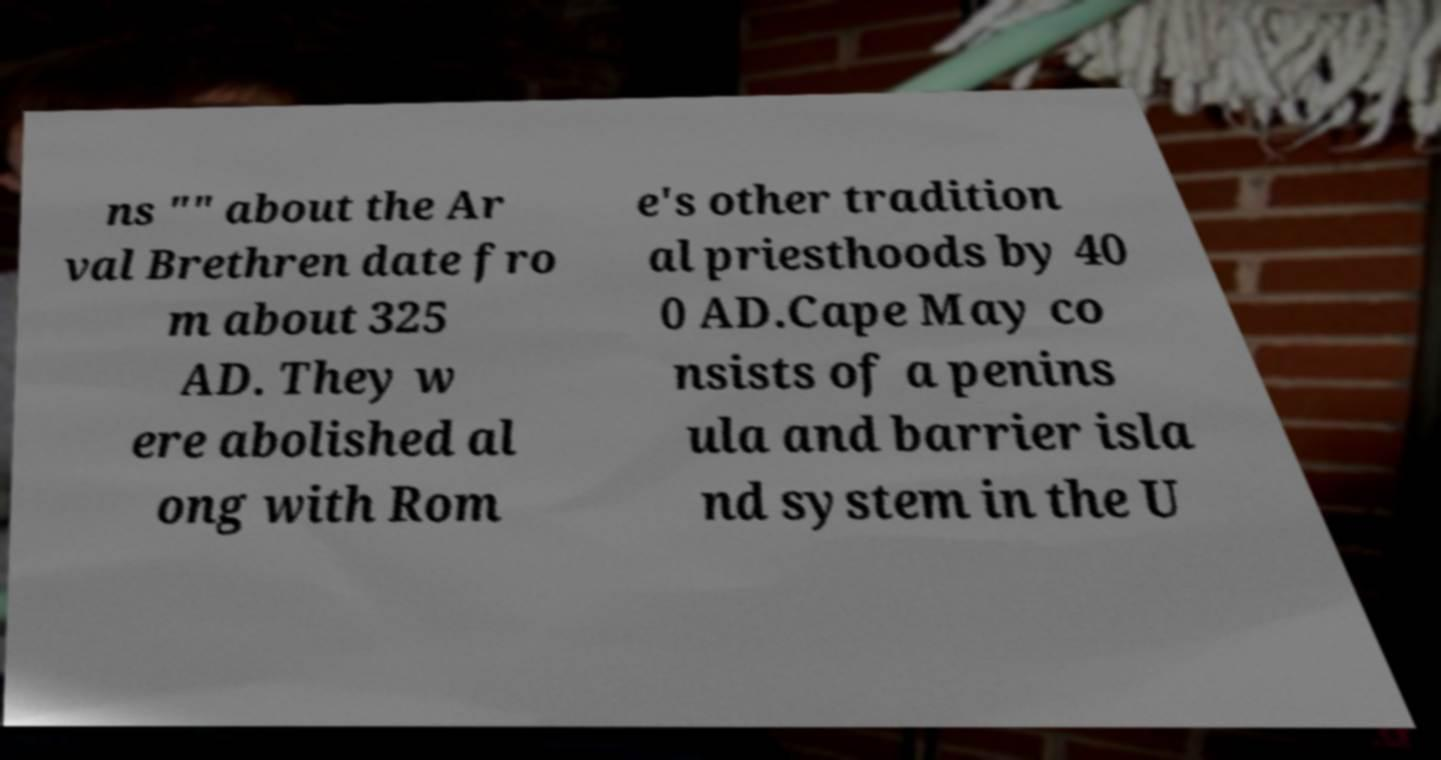For documentation purposes, I need the text within this image transcribed. Could you provide that? ns "" about the Ar val Brethren date fro m about 325 AD. They w ere abolished al ong with Rom e's other tradition al priesthoods by 40 0 AD.Cape May co nsists of a penins ula and barrier isla nd system in the U 